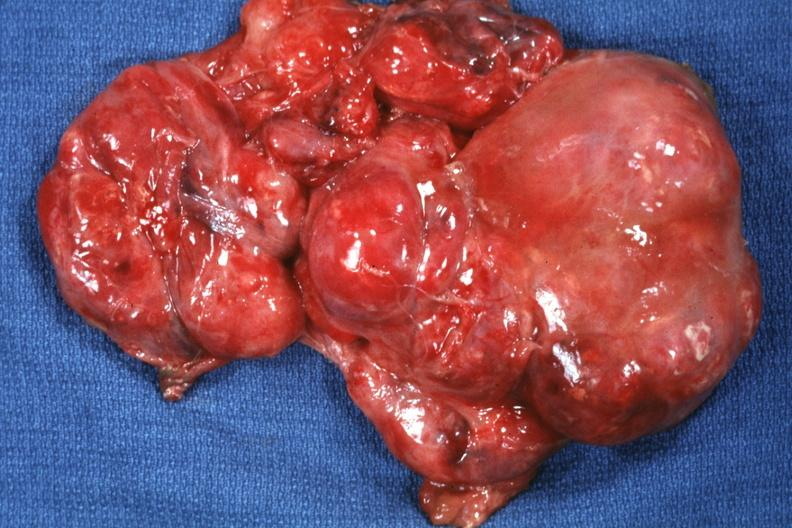s mesothelioma present?
Answer the question using a single word or phrase. No 